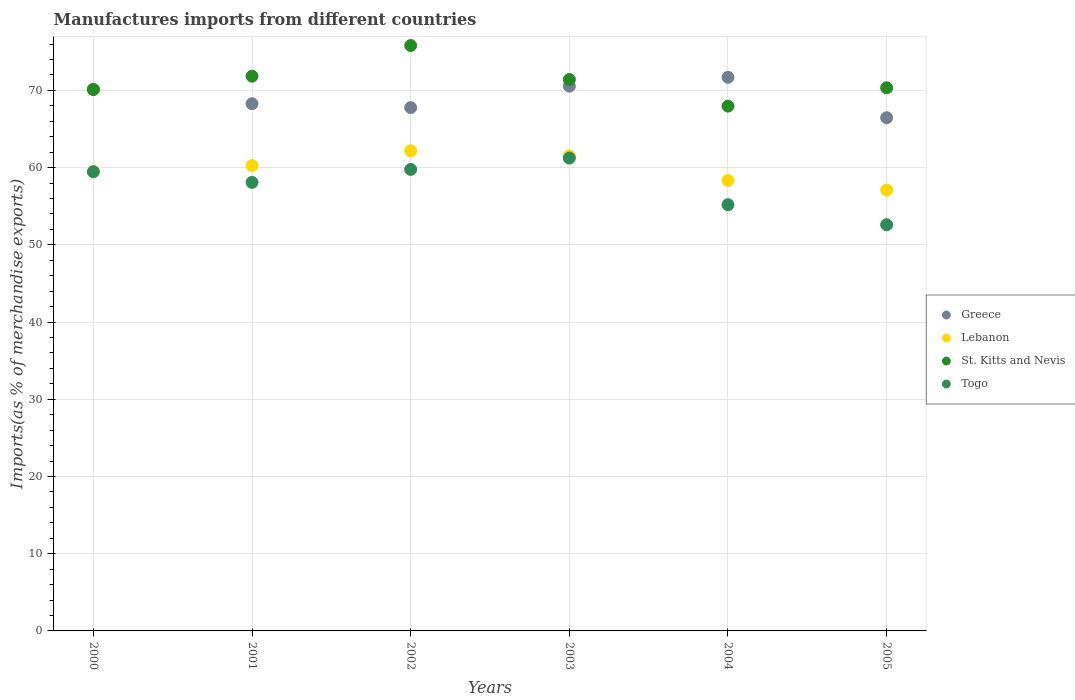How many different coloured dotlines are there?
Your response must be concise. 4. What is the percentage of imports to different countries in St. Kitts and Nevis in 2000?
Provide a short and direct response. 70.11. Across all years, what is the maximum percentage of imports to different countries in Greece?
Make the answer very short. 71.69. Across all years, what is the minimum percentage of imports to different countries in Togo?
Your answer should be compact. 52.6. What is the total percentage of imports to different countries in Togo in the graph?
Provide a short and direct response. 346.38. What is the difference between the percentage of imports to different countries in Togo in 2000 and that in 2002?
Provide a succinct answer. -0.3. What is the difference between the percentage of imports to different countries in Lebanon in 2003 and the percentage of imports to different countries in Greece in 2005?
Offer a terse response. -4.93. What is the average percentage of imports to different countries in St. Kitts and Nevis per year?
Your response must be concise. 71.25. In the year 2004, what is the difference between the percentage of imports to different countries in Togo and percentage of imports to different countries in St. Kitts and Nevis?
Make the answer very short. -12.77. In how many years, is the percentage of imports to different countries in Lebanon greater than 30 %?
Ensure brevity in your answer.  6. What is the ratio of the percentage of imports to different countries in Togo in 2001 to that in 2004?
Your answer should be very brief. 1.05. Is the difference between the percentage of imports to different countries in Togo in 2003 and 2004 greater than the difference between the percentage of imports to different countries in St. Kitts and Nevis in 2003 and 2004?
Your answer should be very brief. Yes. What is the difference between the highest and the second highest percentage of imports to different countries in Togo?
Give a very brief answer. 1.47. What is the difference between the highest and the lowest percentage of imports to different countries in Lebanon?
Ensure brevity in your answer.  5.09. In how many years, is the percentage of imports to different countries in Lebanon greater than the average percentage of imports to different countries in Lebanon taken over all years?
Your answer should be compact. 3. Does the percentage of imports to different countries in Togo monotonically increase over the years?
Your answer should be compact. No. How many dotlines are there?
Your response must be concise. 4. Are the values on the major ticks of Y-axis written in scientific E-notation?
Provide a succinct answer. No. Does the graph contain any zero values?
Provide a short and direct response. No. Does the graph contain grids?
Give a very brief answer. Yes. Where does the legend appear in the graph?
Provide a short and direct response. Center right. How many legend labels are there?
Give a very brief answer. 4. What is the title of the graph?
Offer a terse response. Manufactures imports from different countries. What is the label or title of the Y-axis?
Provide a succinct answer. Imports(as % of merchandise exports). What is the Imports(as % of merchandise exports) of Greece in 2000?
Your answer should be very brief. 70.15. What is the Imports(as % of merchandise exports) of Lebanon in 2000?
Offer a terse response. 59.49. What is the Imports(as % of merchandise exports) in St. Kitts and Nevis in 2000?
Offer a very short reply. 70.11. What is the Imports(as % of merchandise exports) of Togo in 2000?
Keep it short and to the point. 59.47. What is the Imports(as % of merchandise exports) in Greece in 2001?
Make the answer very short. 68.28. What is the Imports(as % of merchandise exports) of Lebanon in 2001?
Offer a terse response. 60.27. What is the Imports(as % of merchandise exports) in St. Kitts and Nevis in 2001?
Provide a succinct answer. 71.85. What is the Imports(as % of merchandise exports) in Togo in 2001?
Your answer should be compact. 58.09. What is the Imports(as % of merchandise exports) of Greece in 2002?
Your answer should be very brief. 67.78. What is the Imports(as % of merchandise exports) of Lebanon in 2002?
Offer a very short reply. 62.19. What is the Imports(as % of merchandise exports) in St. Kitts and Nevis in 2002?
Your answer should be very brief. 75.82. What is the Imports(as % of merchandise exports) in Togo in 2002?
Offer a very short reply. 59.77. What is the Imports(as % of merchandise exports) of Greece in 2003?
Your answer should be very brief. 70.55. What is the Imports(as % of merchandise exports) in Lebanon in 2003?
Make the answer very short. 61.54. What is the Imports(as % of merchandise exports) in St. Kitts and Nevis in 2003?
Make the answer very short. 71.41. What is the Imports(as % of merchandise exports) in Togo in 2003?
Provide a succinct answer. 61.24. What is the Imports(as % of merchandise exports) in Greece in 2004?
Give a very brief answer. 71.69. What is the Imports(as % of merchandise exports) of Lebanon in 2004?
Make the answer very short. 58.35. What is the Imports(as % of merchandise exports) of St. Kitts and Nevis in 2004?
Provide a succinct answer. 67.97. What is the Imports(as % of merchandise exports) of Togo in 2004?
Offer a terse response. 55.2. What is the Imports(as % of merchandise exports) of Greece in 2005?
Your response must be concise. 66.47. What is the Imports(as % of merchandise exports) in Lebanon in 2005?
Give a very brief answer. 57.1. What is the Imports(as % of merchandise exports) of St. Kitts and Nevis in 2005?
Offer a terse response. 70.34. What is the Imports(as % of merchandise exports) of Togo in 2005?
Make the answer very short. 52.6. Across all years, what is the maximum Imports(as % of merchandise exports) of Greece?
Your response must be concise. 71.69. Across all years, what is the maximum Imports(as % of merchandise exports) of Lebanon?
Offer a terse response. 62.19. Across all years, what is the maximum Imports(as % of merchandise exports) of St. Kitts and Nevis?
Provide a succinct answer. 75.82. Across all years, what is the maximum Imports(as % of merchandise exports) of Togo?
Make the answer very short. 61.24. Across all years, what is the minimum Imports(as % of merchandise exports) of Greece?
Your answer should be very brief. 66.47. Across all years, what is the minimum Imports(as % of merchandise exports) in Lebanon?
Provide a succinct answer. 57.1. Across all years, what is the minimum Imports(as % of merchandise exports) in St. Kitts and Nevis?
Ensure brevity in your answer.  67.97. Across all years, what is the minimum Imports(as % of merchandise exports) in Togo?
Your answer should be compact. 52.6. What is the total Imports(as % of merchandise exports) in Greece in the graph?
Your answer should be very brief. 414.92. What is the total Imports(as % of merchandise exports) in Lebanon in the graph?
Your answer should be compact. 358.93. What is the total Imports(as % of merchandise exports) of St. Kitts and Nevis in the graph?
Provide a short and direct response. 427.5. What is the total Imports(as % of merchandise exports) of Togo in the graph?
Provide a short and direct response. 346.38. What is the difference between the Imports(as % of merchandise exports) of Greece in 2000 and that in 2001?
Offer a very short reply. 1.86. What is the difference between the Imports(as % of merchandise exports) in Lebanon in 2000 and that in 2001?
Your answer should be very brief. -0.78. What is the difference between the Imports(as % of merchandise exports) in St. Kitts and Nevis in 2000 and that in 2001?
Offer a terse response. -1.74. What is the difference between the Imports(as % of merchandise exports) in Togo in 2000 and that in 2001?
Give a very brief answer. 1.38. What is the difference between the Imports(as % of merchandise exports) in Greece in 2000 and that in 2002?
Ensure brevity in your answer.  2.37. What is the difference between the Imports(as % of merchandise exports) in Lebanon in 2000 and that in 2002?
Provide a succinct answer. -2.7. What is the difference between the Imports(as % of merchandise exports) in St. Kitts and Nevis in 2000 and that in 2002?
Provide a succinct answer. -5.7. What is the difference between the Imports(as % of merchandise exports) of Togo in 2000 and that in 2002?
Keep it short and to the point. -0.3. What is the difference between the Imports(as % of merchandise exports) in Greece in 2000 and that in 2003?
Offer a very short reply. -0.4. What is the difference between the Imports(as % of merchandise exports) in Lebanon in 2000 and that in 2003?
Provide a short and direct response. -2.05. What is the difference between the Imports(as % of merchandise exports) in St. Kitts and Nevis in 2000 and that in 2003?
Provide a succinct answer. -1.3. What is the difference between the Imports(as % of merchandise exports) of Togo in 2000 and that in 2003?
Offer a terse response. -1.77. What is the difference between the Imports(as % of merchandise exports) in Greece in 2000 and that in 2004?
Ensure brevity in your answer.  -1.55. What is the difference between the Imports(as % of merchandise exports) in Lebanon in 2000 and that in 2004?
Your answer should be very brief. 1.14. What is the difference between the Imports(as % of merchandise exports) in St. Kitts and Nevis in 2000 and that in 2004?
Offer a terse response. 2.14. What is the difference between the Imports(as % of merchandise exports) of Togo in 2000 and that in 2004?
Offer a terse response. 4.27. What is the difference between the Imports(as % of merchandise exports) of Greece in 2000 and that in 2005?
Your answer should be very brief. 3.68. What is the difference between the Imports(as % of merchandise exports) in Lebanon in 2000 and that in 2005?
Your answer should be very brief. 2.39. What is the difference between the Imports(as % of merchandise exports) of St. Kitts and Nevis in 2000 and that in 2005?
Your answer should be very brief. -0.23. What is the difference between the Imports(as % of merchandise exports) of Togo in 2000 and that in 2005?
Your answer should be very brief. 6.87. What is the difference between the Imports(as % of merchandise exports) in Greece in 2001 and that in 2002?
Offer a terse response. 0.51. What is the difference between the Imports(as % of merchandise exports) of Lebanon in 2001 and that in 2002?
Offer a very short reply. -1.92. What is the difference between the Imports(as % of merchandise exports) in St. Kitts and Nevis in 2001 and that in 2002?
Make the answer very short. -3.97. What is the difference between the Imports(as % of merchandise exports) of Togo in 2001 and that in 2002?
Give a very brief answer. -1.68. What is the difference between the Imports(as % of merchandise exports) of Greece in 2001 and that in 2003?
Give a very brief answer. -2.27. What is the difference between the Imports(as % of merchandise exports) of Lebanon in 2001 and that in 2003?
Provide a succinct answer. -1.27. What is the difference between the Imports(as % of merchandise exports) of St. Kitts and Nevis in 2001 and that in 2003?
Give a very brief answer. 0.43. What is the difference between the Imports(as % of merchandise exports) of Togo in 2001 and that in 2003?
Ensure brevity in your answer.  -3.15. What is the difference between the Imports(as % of merchandise exports) of Greece in 2001 and that in 2004?
Make the answer very short. -3.41. What is the difference between the Imports(as % of merchandise exports) in Lebanon in 2001 and that in 2004?
Make the answer very short. 1.92. What is the difference between the Imports(as % of merchandise exports) in St. Kitts and Nevis in 2001 and that in 2004?
Your answer should be compact. 3.88. What is the difference between the Imports(as % of merchandise exports) of Togo in 2001 and that in 2004?
Make the answer very short. 2.89. What is the difference between the Imports(as % of merchandise exports) in Greece in 2001 and that in 2005?
Make the answer very short. 1.81. What is the difference between the Imports(as % of merchandise exports) in Lebanon in 2001 and that in 2005?
Make the answer very short. 3.17. What is the difference between the Imports(as % of merchandise exports) in St. Kitts and Nevis in 2001 and that in 2005?
Make the answer very short. 1.51. What is the difference between the Imports(as % of merchandise exports) in Togo in 2001 and that in 2005?
Give a very brief answer. 5.49. What is the difference between the Imports(as % of merchandise exports) in Greece in 2002 and that in 2003?
Your answer should be very brief. -2.77. What is the difference between the Imports(as % of merchandise exports) of Lebanon in 2002 and that in 2003?
Your answer should be compact. 0.65. What is the difference between the Imports(as % of merchandise exports) in St. Kitts and Nevis in 2002 and that in 2003?
Provide a short and direct response. 4.4. What is the difference between the Imports(as % of merchandise exports) of Togo in 2002 and that in 2003?
Your answer should be compact. -1.47. What is the difference between the Imports(as % of merchandise exports) of Greece in 2002 and that in 2004?
Ensure brevity in your answer.  -3.92. What is the difference between the Imports(as % of merchandise exports) in Lebanon in 2002 and that in 2004?
Offer a terse response. 3.84. What is the difference between the Imports(as % of merchandise exports) in St. Kitts and Nevis in 2002 and that in 2004?
Your response must be concise. 7.85. What is the difference between the Imports(as % of merchandise exports) of Togo in 2002 and that in 2004?
Offer a very short reply. 4.57. What is the difference between the Imports(as % of merchandise exports) in Greece in 2002 and that in 2005?
Your answer should be compact. 1.31. What is the difference between the Imports(as % of merchandise exports) in Lebanon in 2002 and that in 2005?
Your response must be concise. 5.09. What is the difference between the Imports(as % of merchandise exports) in St. Kitts and Nevis in 2002 and that in 2005?
Your response must be concise. 5.47. What is the difference between the Imports(as % of merchandise exports) in Togo in 2002 and that in 2005?
Ensure brevity in your answer.  7.17. What is the difference between the Imports(as % of merchandise exports) in Greece in 2003 and that in 2004?
Offer a terse response. -1.14. What is the difference between the Imports(as % of merchandise exports) of Lebanon in 2003 and that in 2004?
Give a very brief answer. 3.19. What is the difference between the Imports(as % of merchandise exports) of St. Kitts and Nevis in 2003 and that in 2004?
Keep it short and to the point. 3.45. What is the difference between the Imports(as % of merchandise exports) of Togo in 2003 and that in 2004?
Make the answer very short. 6.04. What is the difference between the Imports(as % of merchandise exports) in Greece in 2003 and that in 2005?
Ensure brevity in your answer.  4.08. What is the difference between the Imports(as % of merchandise exports) in Lebanon in 2003 and that in 2005?
Your response must be concise. 4.44. What is the difference between the Imports(as % of merchandise exports) of St. Kitts and Nevis in 2003 and that in 2005?
Provide a succinct answer. 1.07. What is the difference between the Imports(as % of merchandise exports) in Togo in 2003 and that in 2005?
Give a very brief answer. 8.64. What is the difference between the Imports(as % of merchandise exports) of Greece in 2004 and that in 2005?
Your answer should be compact. 5.23. What is the difference between the Imports(as % of merchandise exports) of Lebanon in 2004 and that in 2005?
Keep it short and to the point. 1.25. What is the difference between the Imports(as % of merchandise exports) in St. Kitts and Nevis in 2004 and that in 2005?
Provide a succinct answer. -2.38. What is the difference between the Imports(as % of merchandise exports) in Togo in 2004 and that in 2005?
Your answer should be compact. 2.6. What is the difference between the Imports(as % of merchandise exports) of Greece in 2000 and the Imports(as % of merchandise exports) of Lebanon in 2001?
Give a very brief answer. 9.88. What is the difference between the Imports(as % of merchandise exports) in Greece in 2000 and the Imports(as % of merchandise exports) in St. Kitts and Nevis in 2001?
Offer a very short reply. -1.7. What is the difference between the Imports(as % of merchandise exports) in Greece in 2000 and the Imports(as % of merchandise exports) in Togo in 2001?
Give a very brief answer. 12.05. What is the difference between the Imports(as % of merchandise exports) in Lebanon in 2000 and the Imports(as % of merchandise exports) in St. Kitts and Nevis in 2001?
Keep it short and to the point. -12.36. What is the difference between the Imports(as % of merchandise exports) in Lebanon in 2000 and the Imports(as % of merchandise exports) in Togo in 2001?
Ensure brevity in your answer.  1.4. What is the difference between the Imports(as % of merchandise exports) in St. Kitts and Nevis in 2000 and the Imports(as % of merchandise exports) in Togo in 2001?
Your answer should be compact. 12.02. What is the difference between the Imports(as % of merchandise exports) of Greece in 2000 and the Imports(as % of merchandise exports) of Lebanon in 2002?
Ensure brevity in your answer.  7.96. What is the difference between the Imports(as % of merchandise exports) of Greece in 2000 and the Imports(as % of merchandise exports) of St. Kitts and Nevis in 2002?
Provide a succinct answer. -5.67. What is the difference between the Imports(as % of merchandise exports) of Greece in 2000 and the Imports(as % of merchandise exports) of Togo in 2002?
Provide a succinct answer. 10.38. What is the difference between the Imports(as % of merchandise exports) of Lebanon in 2000 and the Imports(as % of merchandise exports) of St. Kitts and Nevis in 2002?
Your response must be concise. -16.33. What is the difference between the Imports(as % of merchandise exports) of Lebanon in 2000 and the Imports(as % of merchandise exports) of Togo in 2002?
Provide a succinct answer. -0.28. What is the difference between the Imports(as % of merchandise exports) in St. Kitts and Nevis in 2000 and the Imports(as % of merchandise exports) in Togo in 2002?
Offer a terse response. 10.34. What is the difference between the Imports(as % of merchandise exports) of Greece in 2000 and the Imports(as % of merchandise exports) of Lebanon in 2003?
Provide a short and direct response. 8.61. What is the difference between the Imports(as % of merchandise exports) of Greece in 2000 and the Imports(as % of merchandise exports) of St. Kitts and Nevis in 2003?
Offer a very short reply. -1.27. What is the difference between the Imports(as % of merchandise exports) in Greece in 2000 and the Imports(as % of merchandise exports) in Togo in 2003?
Keep it short and to the point. 8.9. What is the difference between the Imports(as % of merchandise exports) of Lebanon in 2000 and the Imports(as % of merchandise exports) of St. Kitts and Nevis in 2003?
Ensure brevity in your answer.  -11.93. What is the difference between the Imports(as % of merchandise exports) of Lebanon in 2000 and the Imports(as % of merchandise exports) of Togo in 2003?
Provide a succinct answer. -1.75. What is the difference between the Imports(as % of merchandise exports) in St. Kitts and Nevis in 2000 and the Imports(as % of merchandise exports) in Togo in 2003?
Your answer should be very brief. 8.87. What is the difference between the Imports(as % of merchandise exports) in Greece in 2000 and the Imports(as % of merchandise exports) in Lebanon in 2004?
Give a very brief answer. 11.8. What is the difference between the Imports(as % of merchandise exports) in Greece in 2000 and the Imports(as % of merchandise exports) in St. Kitts and Nevis in 2004?
Your answer should be very brief. 2.18. What is the difference between the Imports(as % of merchandise exports) in Greece in 2000 and the Imports(as % of merchandise exports) in Togo in 2004?
Give a very brief answer. 14.94. What is the difference between the Imports(as % of merchandise exports) in Lebanon in 2000 and the Imports(as % of merchandise exports) in St. Kitts and Nevis in 2004?
Your answer should be compact. -8.48. What is the difference between the Imports(as % of merchandise exports) in Lebanon in 2000 and the Imports(as % of merchandise exports) in Togo in 2004?
Provide a succinct answer. 4.29. What is the difference between the Imports(as % of merchandise exports) of St. Kitts and Nevis in 2000 and the Imports(as % of merchandise exports) of Togo in 2004?
Make the answer very short. 14.91. What is the difference between the Imports(as % of merchandise exports) in Greece in 2000 and the Imports(as % of merchandise exports) in Lebanon in 2005?
Provide a short and direct response. 13.05. What is the difference between the Imports(as % of merchandise exports) of Greece in 2000 and the Imports(as % of merchandise exports) of St. Kitts and Nevis in 2005?
Keep it short and to the point. -0.2. What is the difference between the Imports(as % of merchandise exports) in Greece in 2000 and the Imports(as % of merchandise exports) in Togo in 2005?
Offer a terse response. 17.54. What is the difference between the Imports(as % of merchandise exports) in Lebanon in 2000 and the Imports(as % of merchandise exports) in St. Kitts and Nevis in 2005?
Keep it short and to the point. -10.86. What is the difference between the Imports(as % of merchandise exports) of Lebanon in 2000 and the Imports(as % of merchandise exports) of Togo in 2005?
Keep it short and to the point. 6.88. What is the difference between the Imports(as % of merchandise exports) in St. Kitts and Nevis in 2000 and the Imports(as % of merchandise exports) in Togo in 2005?
Your answer should be compact. 17.51. What is the difference between the Imports(as % of merchandise exports) in Greece in 2001 and the Imports(as % of merchandise exports) in Lebanon in 2002?
Give a very brief answer. 6.1. What is the difference between the Imports(as % of merchandise exports) in Greece in 2001 and the Imports(as % of merchandise exports) in St. Kitts and Nevis in 2002?
Make the answer very short. -7.53. What is the difference between the Imports(as % of merchandise exports) of Greece in 2001 and the Imports(as % of merchandise exports) of Togo in 2002?
Your answer should be very brief. 8.51. What is the difference between the Imports(as % of merchandise exports) of Lebanon in 2001 and the Imports(as % of merchandise exports) of St. Kitts and Nevis in 2002?
Your response must be concise. -15.54. What is the difference between the Imports(as % of merchandise exports) of Lebanon in 2001 and the Imports(as % of merchandise exports) of Togo in 2002?
Provide a short and direct response. 0.5. What is the difference between the Imports(as % of merchandise exports) in St. Kitts and Nevis in 2001 and the Imports(as % of merchandise exports) in Togo in 2002?
Your response must be concise. 12.08. What is the difference between the Imports(as % of merchandise exports) of Greece in 2001 and the Imports(as % of merchandise exports) of Lebanon in 2003?
Your answer should be compact. 6.74. What is the difference between the Imports(as % of merchandise exports) of Greece in 2001 and the Imports(as % of merchandise exports) of St. Kitts and Nevis in 2003?
Provide a short and direct response. -3.13. What is the difference between the Imports(as % of merchandise exports) in Greece in 2001 and the Imports(as % of merchandise exports) in Togo in 2003?
Your answer should be very brief. 7.04. What is the difference between the Imports(as % of merchandise exports) of Lebanon in 2001 and the Imports(as % of merchandise exports) of St. Kitts and Nevis in 2003?
Your answer should be very brief. -11.14. What is the difference between the Imports(as % of merchandise exports) in Lebanon in 2001 and the Imports(as % of merchandise exports) in Togo in 2003?
Give a very brief answer. -0.97. What is the difference between the Imports(as % of merchandise exports) of St. Kitts and Nevis in 2001 and the Imports(as % of merchandise exports) of Togo in 2003?
Keep it short and to the point. 10.61. What is the difference between the Imports(as % of merchandise exports) of Greece in 2001 and the Imports(as % of merchandise exports) of Lebanon in 2004?
Keep it short and to the point. 9.94. What is the difference between the Imports(as % of merchandise exports) of Greece in 2001 and the Imports(as % of merchandise exports) of St. Kitts and Nevis in 2004?
Give a very brief answer. 0.31. What is the difference between the Imports(as % of merchandise exports) of Greece in 2001 and the Imports(as % of merchandise exports) of Togo in 2004?
Ensure brevity in your answer.  13.08. What is the difference between the Imports(as % of merchandise exports) of Lebanon in 2001 and the Imports(as % of merchandise exports) of St. Kitts and Nevis in 2004?
Give a very brief answer. -7.7. What is the difference between the Imports(as % of merchandise exports) in Lebanon in 2001 and the Imports(as % of merchandise exports) in Togo in 2004?
Your answer should be very brief. 5.07. What is the difference between the Imports(as % of merchandise exports) of St. Kitts and Nevis in 2001 and the Imports(as % of merchandise exports) of Togo in 2004?
Your response must be concise. 16.65. What is the difference between the Imports(as % of merchandise exports) of Greece in 2001 and the Imports(as % of merchandise exports) of Lebanon in 2005?
Offer a very short reply. 11.18. What is the difference between the Imports(as % of merchandise exports) of Greece in 2001 and the Imports(as % of merchandise exports) of St. Kitts and Nevis in 2005?
Make the answer very short. -2.06. What is the difference between the Imports(as % of merchandise exports) of Greece in 2001 and the Imports(as % of merchandise exports) of Togo in 2005?
Make the answer very short. 15.68. What is the difference between the Imports(as % of merchandise exports) of Lebanon in 2001 and the Imports(as % of merchandise exports) of St. Kitts and Nevis in 2005?
Provide a short and direct response. -10.07. What is the difference between the Imports(as % of merchandise exports) in Lebanon in 2001 and the Imports(as % of merchandise exports) in Togo in 2005?
Your answer should be compact. 7.67. What is the difference between the Imports(as % of merchandise exports) of St. Kitts and Nevis in 2001 and the Imports(as % of merchandise exports) of Togo in 2005?
Offer a very short reply. 19.25. What is the difference between the Imports(as % of merchandise exports) of Greece in 2002 and the Imports(as % of merchandise exports) of Lebanon in 2003?
Your answer should be very brief. 6.24. What is the difference between the Imports(as % of merchandise exports) in Greece in 2002 and the Imports(as % of merchandise exports) in St. Kitts and Nevis in 2003?
Provide a succinct answer. -3.64. What is the difference between the Imports(as % of merchandise exports) of Greece in 2002 and the Imports(as % of merchandise exports) of Togo in 2003?
Make the answer very short. 6.53. What is the difference between the Imports(as % of merchandise exports) of Lebanon in 2002 and the Imports(as % of merchandise exports) of St. Kitts and Nevis in 2003?
Provide a short and direct response. -9.23. What is the difference between the Imports(as % of merchandise exports) in Lebanon in 2002 and the Imports(as % of merchandise exports) in Togo in 2003?
Your answer should be very brief. 0.94. What is the difference between the Imports(as % of merchandise exports) in St. Kitts and Nevis in 2002 and the Imports(as % of merchandise exports) in Togo in 2003?
Offer a terse response. 14.57. What is the difference between the Imports(as % of merchandise exports) of Greece in 2002 and the Imports(as % of merchandise exports) of Lebanon in 2004?
Your answer should be very brief. 9.43. What is the difference between the Imports(as % of merchandise exports) in Greece in 2002 and the Imports(as % of merchandise exports) in St. Kitts and Nevis in 2004?
Offer a very short reply. -0.19. What is the difference between the Imports(as % of merchandise exports) of Greece in 2002 and the Imports(as % of merchandise exports) of Togo in 2004?
Provide a succinct answer. 12.57. What is the difference between the Imports(as % of merchandise exports) in Lebanon in 2002 and the Imports(as % of merchandise exports) in St. Kitts and Nevis in 2004?
Provide a succinct answer. -5.78. What is the difference between the Imports(as % of merchandise exports) of Lebanon in 2002 and the Imports(as % of merchandise exports) of Togo in 2004?
Ensure brevity in your answer.  6.98. What is the difference between the Imports(as % of merchandise exports) in St. Kitts and Nevis in 2002 and the Imports(as % of merchandise exports) in Togo in 2004?
Your answer should be compact. 20.61. What is the difference between the Imports(as % of merchandise exports) in Greece in 2002 and the Imports(as % of merchandise exports) in Lebanon in 2005?
Your answer should be compact. 10.68. What is the difference between the Imports(as % of merchandise exports) of Greece in 2002 and the Imports(as % of merchandise exports) of St. Kitts and Nevis in 2005?
Your answer should be very brief. -2.57. What is the difference between the Imports(as % of merchandise exports) in Greece in 2002 and the Imports(as % of merchandise exports) in Togo in 2005?
Your answer should be very brief. 15.17. What is the difference between the Imports(as % of merchandise exports) of Lebanon in 2002 and the Imports(as % of merchandise exports) of St. Kitts and Nevis in 2005?
Provide a short and direct response. -8.16. What is the difference between the Imports(as % of merchandise exports) of Lebanon in 2002 and the Imports(as % of merchandise exports) of Togo in 2005?
Offer a terse response. 9.58. What is the difference between the Imports(as % of merchandise exports) of St. Kitts and Nevis in 2002 and the Imports(as % of merchandise exports) of Togo in 2005?
Give a very brief answer. 23.21. What is the difference between the Imports(as % of merchandise exports) in Greece in 2003 and the Imports(as % of merchandise exports) in Lebanon in 2004?
Your answer should be compact. 12.2. What is the difference between the Imports(as % of merchandise exports) in Greece in 2003 and the Imports(as % of merchandise exports) in St. Kitts and Nevis in 2004?
Your answer should be compact. 2.58. What is the difference between the Imports(as % of merchandise exports) in Greece in 2003 and the Imports(as % of merchandise exports) in Togo in 2004?
Offer a very short reply. 15.35. What is the difference between the Imports(as % of merchandise exports) of Lebanon in 2003 and the Imports(as % of merchandise exports) of St. Kitts and Nevis in 2004?
Provide a short and direct response. -6.43. What is the difference between the Imports(as % of merchandise exports) in Lebanon in 2003 and the Imports(as % of merchandise exports) in Togo in 2004?
Ensure brevity in your answer.  6.34. What is the difference between the Imports(as % of merchandise exports) in St. Kitts and Nevis in 2003 and the Imports(as % of merchandise exports) in Togo in 2004?
Ensure brevity in your answer.  16.21. What is the difference between the Imports(as % of merchandise exports) in Greece in 2003 and the Imports(as % of merchandise exports) in Lebanon in 2005?
Your answer should be very brief. 13.45. What is the difference between the Imports(as % of merchandise exports) of Greece in 2003 and the Imports(as % of merchandise exports) of St. Kitts and Nevis in 2005?
Ensure brevity in your answer.  0.21. What is the difference between the Imports(as % of merchandise exports) of Greece in 2003 and the Imports(as % of merchandise exports) of Togo in 2005?
Give a very brief answer. 17.95. What is the difference between the Imports(as % of merchandise exports) of Lebanon in 2003 and the Imports(as % of merchandise exports) of St. Kitts and Nevis in 2005?
Offer a terse response. -8.8. What is the difference between the Imports(as % of merchandise exports) in Lebanon in 2003 and the Imports(as % of merchandise exports) in Togo in 2005?
Offer a very short reply. 8.94. What is the difference between the Imports(as % of merchandise exports) in St. Kitts and Nevis in 2003 and the Imports(as % of merchandise exports) in Togo in 2005?
Provide a short and direct response. 18.81. What is the difference between the Imports(as % of merchandise exports) in Greece in 2004 and the Imports(as % of merchandise exports) in Lebanon in 2005?
Provide a short and direct response. 14.6. What is the difference between the Imports(as % of merchandise exports) of Greece in 2004 and the Imports(as % of merchandise exports) of St. Kitts and Nevis in 2005?
Your response must be concise. 1.35. What is the difference between the Imports(as % of merchandise exports) in Greece in 2004 and the Imports(as % of merchandise exports) in Togo in 2005?
Your answer should be compact. 19.09. What is the difference between the Imports(as % of merchandise exports) of Lebanon in 2004 and the Imports(as % of merchandise exports) of St. Kitts and Nevis in 2005?
Keep it short and to the point. -12. What is the difference between the Imports(as % of merchandise exports) in Lebanon in 2004 and the Imports(as % of merchandise exports) in Togo in 2005?
Offer a very short reply. 5.74. What is the difference between the Imports(as % of merchandise exports) of St. Kitts and Nevis in 2004 and the Imports(as % of merchandise exports) of Togo in 2005?
Ensure brevity in your answer.  15.36. What is the average Imports(as % of merchandise exports) in Greece per year?
Provide a succinct answer. 69.15. What is the average Imports(as % of merchandise exports) in Lebanon per year?
Ensure brevity in your answer.  59.82. What is the average Imports(as % of merchandise exports) in St. Kitts and Nevis per year?
Your answer should be very brief. 71.25. What is the average Imports(as % of merchandise exports) in Togo per year?
Give a very brief answer. 57.73. In the year 2000, what is the difference between the Imports(as % of merchandise exports) of Greece and Imports(as % of merchandise exports) of Lebanon?
Offer a very short reply. 10.66. In the year 2000, what is the difference between the Imports(as % of merchandise exports) in Greece and Imports(as % of merchandise exports) in St. Kitts and Nevis?
Your answer should be very brief. 0.03. In the year 2000, what is the difference between the Imports(as % of merchandise exports) in Greece and Imports(as % of merchandise exports) in Togo?
Your answer should be compact. 10.67. In the year 2000, what is the difference between the Imports(as % of merchandise exports) in Lebanon and Imports(as % of merchandise exports) in St. Kitts and Nevis?
Your answer should be compact. -10.62. In the year 2000, what is the difference between the Imports(as % of merchandise exports) of Lebanon and Imports(as % of merchandise exports) of Togo?
Give a very brief answer. 0.02. In the year 2000, what is the difference between the Imports(as % of merchandise exports) in St. Kitts and Nevis and Imports(as % of merchandise exports) in Togo?
Your answer should be compact. 10.64. In the year 2001, what is the difference between the Imports(as % of merchandise exports) of Greece and Imports(as % of merchandise exports) of Lebanon?
Your response must be concise. 8.01. In the year 2001, what is the difference between the Imports(as % of merchandise exports) in Greece and Imports(as % of merchandise exports) in St. Kitts and Nevis?
Offer a terse response. -3.57. In the year 2001, what is the difference between the Imports(as % of merchandise exports) of Greece and Imports(as % of merchandise exports) of Togo?
Your response must be concise. 10.19. In the year 2001, what is the difference between the Imports(as % of merchandise exports) of Lebanon and Imports(as % of merchandise exports) of St. Kitts and Nevis?
Ensure brevity in your answer.  -11.58. In the year 2001, what is the difference between the Imports(as % of merchandise exports) of Lebanon and Imports(as % of merchandise exports) of Togo?
Offer a terse response. 2.18. In the year 2001, what is the difference between the Imports(as % of merchandise exports) in St. Kitts and Nevis and Imports(as % of merchandise exports) in Togo?
Your response must be concise. 13.76. In the year 2002, what is the difference between the Imports(as % of merchandise exports) of Greece and Imports(as % of merchandise exports) of Lebanon?
Your answer should be compact. 5.59. In the year 2002, what is the difference between the Imports(as % of merchandise exports) in Greece and Imports(as % of merchandise exports) in St. Kitts and Nevis?
Offer a very short reply. -8.04. In the year 2002, what is the difference between the Imports(as % of merchandise exports) of Greece and Imports(as % of merchandise exports) of Togo?
Provide a short and direct response. 8.01. In the year 2002, what is the difference between the Imports(as % of merchandise exports) of Lebanon and Imports(as % of merchandise exports) of St. Kitts and Nevis?
Give a very brief answer. -13.63. In the year 2002, what is the difference between the Imports(as % of merchandise exports) of Lebanon and Imports(as % of merchandise exports) of Togo?
Ensure brevity in your answer.  2.42. In the year 2002, what is the difference between the Imports(as % of merchandise exports) of St. Kitts and Nevis and Imports(as % of merchandise exports) of Togo?
Give a very brief answer. 16.05. In the year 2003, what is the difference between the Imports(as % of merchandise exports) in Greece and Imports(as % of merchandise exports) in Lebanon?
Offer a very short reply. 9.01. In the year 2003, what is the difference between the Imports(as % of merchandise exports) in Greece and Imports(as % of merchandise exports) in St. Kitts and Nevis?
Give a very brief answer. -0.86. In the year 2003, what is the difference between the Imports(as % of merchandise exports) in Greece and Imports(as % of merchandise exports) in Togo?
Provide a succinct answer. 9.31. In the year 2003, what is the difference between the Imports(as % of merchandise exports) in Lebanon and Imports(as % of merchandise exports) in St. Kitts and Nevis?
Your answer should be very brief. -9.87. In the year 2003, what is the difference between the Imports(as % of merchandise exports) in Lebanon and Imports(as % of merchandise exports) in Togo?
Ensure brevity in your answer.  0.3. In the year 2003, what is the difference between the Imports(as % of merchandise exports) of St. Kitts and Nevis and Imports(as % of merchandise exports) of Togo?
Ensure brevity in your answer.  10.17. In the year 2004, what is the difference between the Imports(as % of merchandise exports) of Greece and Imports(as % of merchandise exports) of Lebanon?
Give a very brief answer. 13.35. In the year 2004, what is the difference between the Imports(as % of merchandise exports) in Greece and Imports(as % of merchandise exports) in St. Kitts and Nevis?
Keep it short and to the point. 3.73. In the year 2004, what is the difference between the Imports(as % of merchandise exports) in Greece and Imports(as % of merchandise exports) in Togo?
Give a very brief answer. 16.49. In the year 2004, what is the difference between the Imports(as % of merchandise exports) of Lebanon and Imports(as % of merchandise exports) of St. Kitts and Nevis?
Offer a terse response. -9.62. In the year 2004, what is the difference between the Imports(as % of merchandise exports) of Lebanon and Imports(as % of merchandise exports) of Togo?
Ensure brevity in your answer.  3.14. In the year 2004, what is the difference between the Imports(as % of merchandise exports) of St. Kitts and Nevis and Imports(as % of merchandise exports) of Togo?
Provide a short and direct response. 12.77. In the year 2005, what is the difference between the Imports(as % of merchandise exports) of Greece and Imports(as % of merchandise exports) of Lebanon?
Make the answer very short. 9.37. In the year 2005, what is the difference between the Imports(as % of merchandise exports) in Greece and Imports(as % of merchandise exports) in St. Kitts and Nevis?
Provide a succinct answer. -3.88. In the year 2005, what is the difference between the Imports(as % of merchandise exports) of Greece and Imports(as % of merchandise exports) of Togo?
Provide a short and direct response. 13.86. In the year 2005, what is the difference between the Imports(as % of merchandise exports) of Lebanon and Imports(as % of merchandise exports) of St. Kitts and Nevis?
Provide a short and direct response. -13.25. In the year 2005, what is the difference between the Imports(as % of merchandise exports) of Lebanon and Imports(as % of merchandise exports) of Togo?
Your answer should be compact. 4.49. In the year 2005, what is the difference between the Imports(as % of merchandise exports) in St. Kitts and Nevis and Imports(as % of merchandise exports) in Togo?
Give a very brief answer. 17.74. What is the ratio of the Imports(as % of merchandise exports) of Greece in 2000 to that in 2001?
Give a very brief answer. 1.03. What is the ratio of the Imports(as % of merchandise exports) of Lebanon in 2000 to that in 2001?
Your response must be concise. 0.99. What is the ratio of the Imports(as % of merchandise exports) in St. Kitts and Nevis in 2000 to that in 2001?
Ensure brevity in your answer.  0.98. What is the ratio of the Imports(as % of merchandise exports) of Togo in 2000 to that in 2001?
Offer a terse response. 1.02. What is the ratio of the Imports(as % of merchandise exports) of Greece in 2000 to that in 2002?
Ensure brevity in your answer.  1.03. What is the ratio of the Imports(as % of merchandise exports) in Lebanon in 2000 to that in 2002?
Ensure brevity in your answer.  0.96. What is the ratio of the Imports(as % of merchandise exports) of St. Kitts and Nevis in 2000 to that in 2002?
Give a very brief answer. 0.92. What is the ratio of the Imports(as % of merchandise exports) in Lebanon in 2000 to that in 2003?
Provide a succinct answer. 0.97. What is the ratio of the Imports(as % of merchandise exports) in St. Kitts and Nevis in 2000 to that in 2003?
Offer a terse response. 0.98. What is the ratio of the Imports(as % of merchandise exports) in Togo in 2000 to that in 2003?
Give a very brief answer. 0.97. What is the ratio of the Imports(as % of merchandise exports) of Greece in 2000 to that in 2004?
Give a very brief answer. 0.98. What is the ratio of the Imports(as % of merchandise exports) in Lebanon in 2000 to that in 2004?
Give a very brief answer. 1.02. What is the ratio of the Imports(as % of merchandise exports) in St. Kitts and Nevis in 2000 to that in 2004?
Your answer should be compact. 1.03. What is the ratio of the Imports(as % of merchandise exports) of Togo in 2000 to that in 2004?
Your response must be concise. 1.08. What is the ratio of the Imports(as % of merchandise exports) of Greece in 2000 to that in 2005?
Provide a succinct answer. 1.06. What is the ratio of the Imports(as % of merchandise exports) of Lebanon in 2000 to that in 2005?
Your answer should be compact. 1.04. What is the ratio of the Imports(as % of merchandise exports) in Togo in 2000 to that in 2005?
Provide a succinct answer. 1.13. What is the ratio of the Imports(as % of merchandise exports) of Greece in 2001 to that in 2002?
Your response must be concise. 1.01. What is the ratio of the Imports(as % of merchandise exports) in Lebanon in 2001 to that in 2002?
Make the answer very short. 0.97. What is the ratio of the Imports(as % of merchandise exports) in St. Kitts and Nevis in 2001 to that in 2002?
Keep it short and to the point. 0.95. What is the ratio of the Imports(as % of merchandise exports) in Togo in 2001 to that in 2002?
Your answer should be compact. 0.97. What is the ratio of the Imports(as % of merchandise exports) of Greece in 2001 to that in 2003?
Keep it short and to the point. 0.97. What is the ratio of the Imports(as % of merchandise exports) in Lebanon in 2001 to that in 2003?
Your answer should be compact. 0.98. What is the ratio of the Imports(as % of merchandise exports) of Togo in 2001 to that in 2003?
Your response must be concise. 0.95. What is the ratio of the Imports(as % of merchandise exports) of Greece in 2001 to that in 2004?
Your answer should be very brief. 0.95. What is the ratio of the Imports(as % of merchandise exports) in Lebanon in 2001 to that in 2004?
Your answer should be compact. 1.03. What is the ratio of the Imports(as % of merchandise exports) in St. Kitts and Nevis in 2001 to that in 2004?
Offer a terse response. 1.06. What is the ratio of the Imports(as % of merchandise exports) in Togo in 2001 to that in 2004?
Ensure brevity in your answer.  1.05. What is the ratio of the Imports(as % of merchandise exports) of Greece in 2001 to that in 2005?
Your answer should be very brief. 1.03. What is the ratio of the Imports(as % of merchandise exports) of Lebanon in 2001 to that in 2005?
Your answer should be very brief. 1.06. What is the ratio of the Imports(as % of merchandise exports) of St. Kitts and Nevis in 2001 to that in 2005?
Keep it short and to the point. 1.02. What is the ratio of the Imports(as % of merchandise exports) of Togo in 2001 to that in 2005?
Make the answer very short. 1.1. What is the ratio of the Imports(as % of merchandise exports) of Greece in 2002 to that in 2003?
Your answer should be very brief. 0.96. What is the ratio of the Imports(as % of merchandise exports) in Lebanon in 2002 to that in 2003?
Keep it short and to the point. 1.01. What is the ratio of the Imports(as % of merchandise exports) in St. Kitts and Nevis in 2002 to that in 2003?
Offer a terse response. 1.06. What is the ratio of the Imports(as % of merchandise exports) of Togo in 2002 to that in 2003?
Your answer should be compact. 0.98. What is the ratio of the Imports(as % of merchandise exports) in Greece in 2002 to that in 2004?
Provide a succinct answer. 0.95. What is the ratio of the Imports(as % of merchandise exports) of Lebanon in 2002 to that in 2004?
Make the answer very short. 1.07. What is the ratio of the Imports(as % of merchandise exports) of St. Kitts and Nevis in 2002 to that in 2004?
Give a very brief answer. 1.12. What is the ratio of the Imports(as % of merchandise exports) in Togo in 2002 to that in 2004?
Ensure brevity in your answer.  1.08. What is the ratio of the Imports(as % of merchandise exports) of Greece in 2002 to that in 2005?
Provide a short and direct response. 1.02. What is the ratio of the Imports(as % of merchandise exports) in Lebanon in 2002 to that in 2005?
Ensure brevity in your answer.  1.09. What is the ratio of the Imports(as % of merchandise exports) in St. Kitts and Nevis in 2002 to that in 2005?
Provide a short and direct response. 1.08. What is the ratio of the Imports(as % of merchandise exports) in Togo in 2002 to that in 2005?
Your answer should be compact. 1.14. What is the ratio of the Imports(as % of merchandise exports) in Greece in 2003 to that in 2004?
Keep it short and to the point. 0.98. What is the ratio of the Imports(as % of merchandise exports) of Lebanon in 2003 to that in 2004?
Make the answer very short. 1.05. What is the ratio of the Imports(as % of merchandise exports) in St. Kitts and Nevis in 2003 to that in 2004?
Offer a terse response. 1.05. What is the ratio of the Imports(as % of merchandise exports) of Togo in 2003 to that in 2004?
Provide a short and direct response. 1.11. What is the ratio of the Imports(as % of merchandise exports) of Greece in 2003 to that in 2005?
Give a very brief answer. 1.06. What is the ratio of the Imports(as % of merchandise exports) in Lebanon in 2003 to that in 2005?
Provide a short and direct response. 1.08. What is the ratio of the Imports(as % of merchandise exports) of St. Kitts and Nevis in 2003 to that in 2005?
Provide a succinct answer. 1.02. What is the ratio of the Imports(as % of merchandise exports) of Togo in 2003 to that in 2005?
Provide a succinct answer. 1.16. What is the ratio of the Imports(as % of merchandise exports) of Greece in 2004 to that in 2005?
Make the answer very short. 1.08. What is the ratio of the Imports(as % of merchandise exports) of Lebanon in 2004 to that in 2005?
Provide a succinct answer. 1.02. What is the ratio of the Imports(as % of merchandise exports) in St. Kitts and Nevis in 2004 to that in 2005?
Your response must be concise. 0.97. What is the ratio of the Imports(as % of merchandise exports) in Togo in 2004 to that in 2005?
Provide a short and direct response. 1.05. What is the difference between the highest and the second highest Imports(as % of merchandise exports) in Greece?
Keep it short and to the point. 1.14. What is the difference between the highest and the second highest Imports(as % of merchandise exports) of Lebanon?
Your answer should be compact. 0.65. What is the difference between the highest and the second highest Imports(as % of merchandise exports) of St. Kitts and Nevis?
Your answer should be compact. 3.97. What is the difference between the highest and the second highest Imports(as % of merchandise exports) of Togo?
Your answer should be compact. 1.47. What is the difference between the highest and the lowest Imports(as % of merchandise exports) in Greece?
Offer a terse response. 5.23. What is the difference between the highest and the lowest Imports(as % of merchandise exports) of Lebanon?
Offer a very short reply. 5.09. What is the difference between the highest and the lowest Imports(as % of merchandise exports) in St. Kitts and Nevis?
Give a very brief answer. 7.85. What is the difference between the highest and the lowest Imports(as % of merchandise exports) of Togo?
Offer a very short reply. 8.64. 